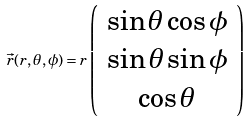<formula> <loc_0><loc_0><loc_500><loc_500>\vec { r } ( r , \theta , \phi ) = r \left ( \begin{array} { c } \sin \theta \cos \phi \\ \sin \theta \sin \phi \\ \cos \theta \end{array} \right )</formula> 